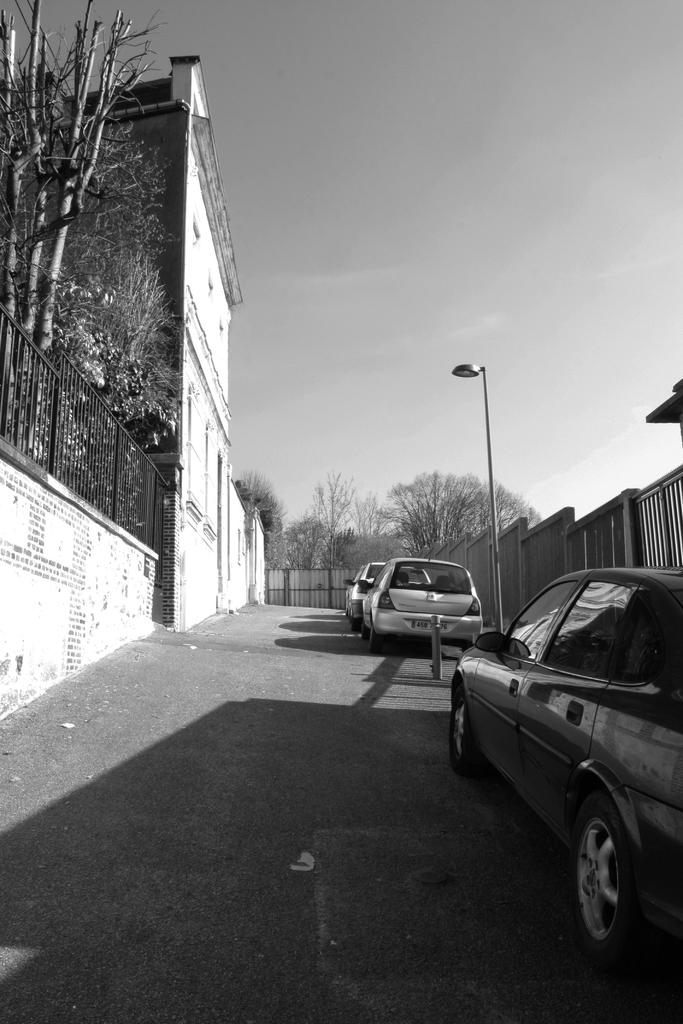What types of objects are present in the image? There are vehicles in the image. What can be seen in the background of the image? There are trees, buildings, a light pole, and the sky visible in the background of the image. What is the color scheme of the image? The image is in black and white. Can you see a squirrel climbing the light pole in the image? There is no squirrel present in the image; it only features vehicles, trees, buildings, a light pole, and the sky. What type of motion is occurring in the image? The image is static, so there is no motion occurring within the image itself. 